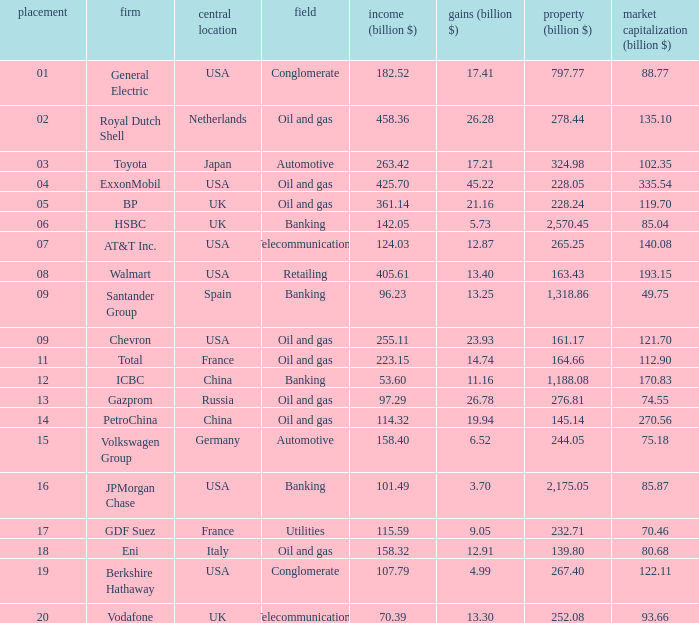What is the total value of assets (billion $) for an oil and gas industry ranked 9 with a market value (billion $) greater than 12 None. 